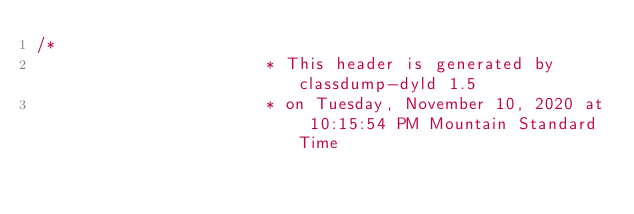Convert code to text. <code><loc_0><loc_0><loc_500><loc_500><_C_>/*
                       * This header is generated by classdump-dyld 1.5
                       * on Tuesday, November 10, 2020 at 10:15:54 PM Mountain Standard Time</code> 